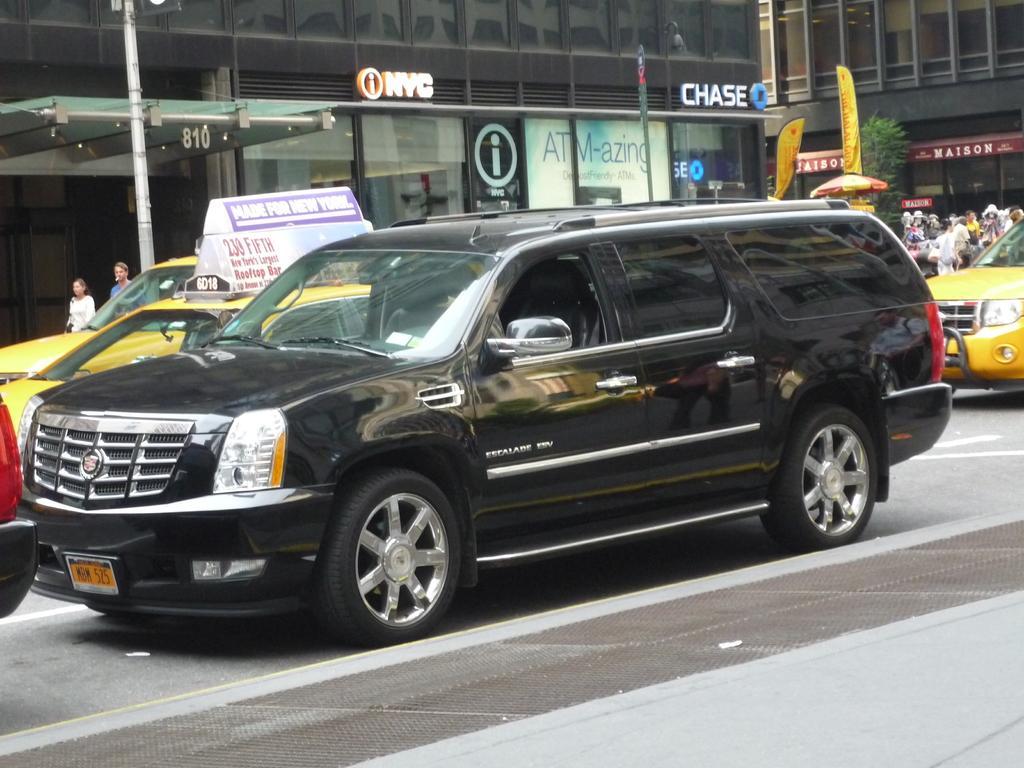In one or two sentences, can you explain what this image depicts? In this image we can see group of vehicles parked on the road. To the left side of the image we can see two persons standing. In the background, we can see buildings with sign boards, poles and an umbrella. 